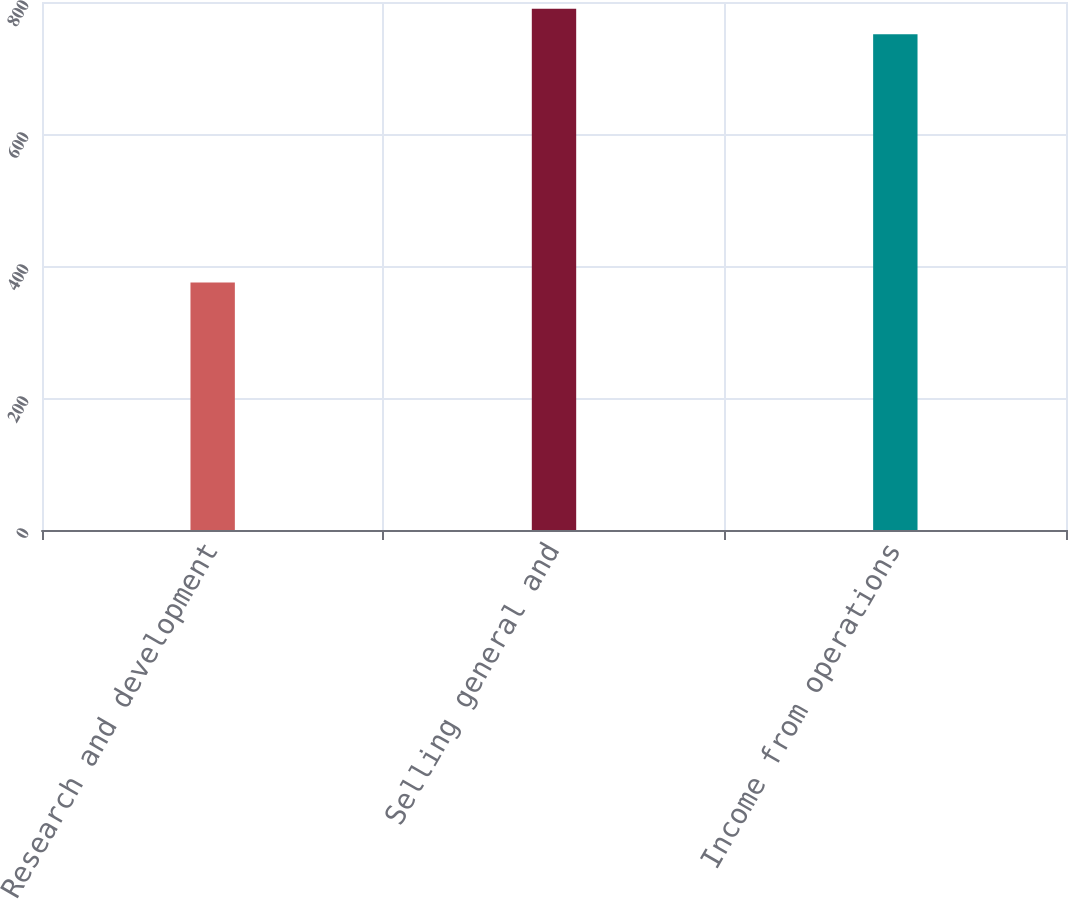Convert chart to OTSL. <chart><loc_0><loc_0><loc_500><loc_500><bar_chart><fcel>Research and development<fcel>Selling general and<fcel>Income from operations<nl><fcel>375<fcel>789.6<fcel>751<nl></chart> 